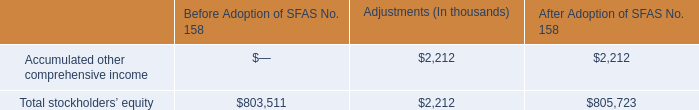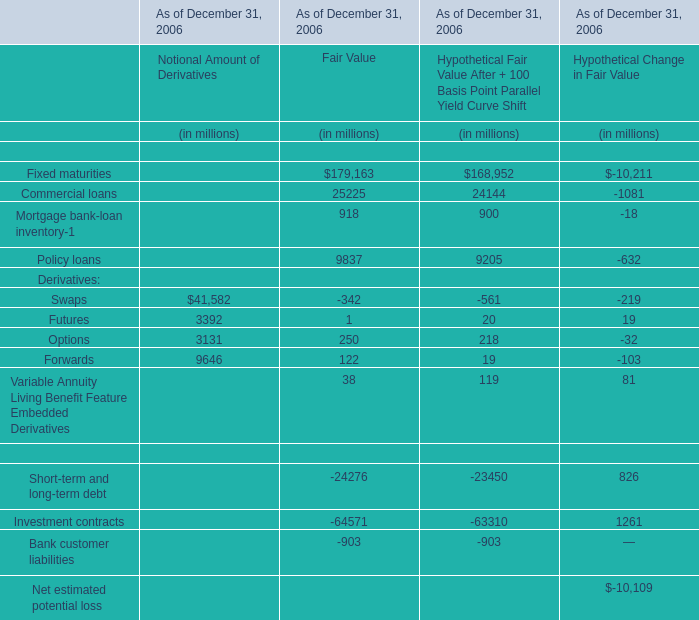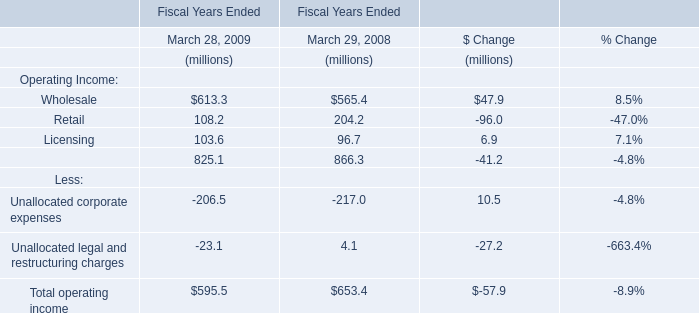What is the Fair Value As of December 31, 2006 for Financial assets with interest rate risk:Commercial loans ? (in million) 
Answer: 25225. 